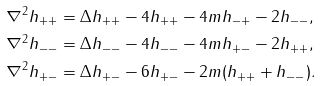<formula> <loc_0><loc_0><loc_500><loc_500>\nabla ^ { 2 } h _ { + + } & = \Delta h _ { + + } - 4 h _ { + + } - 4 m h _ { - + } - 2 h _ { - - } , \\ \nabla ^ { 2 } h _ { - - } & = \Delta h _ { - - } - 4 h _ { - - } - 4 m h _ { + - } - 2 h _ { + + } , \\ \nabla ^ { 2 } h _ { + - } & = \Delta h _ { + - } - 6 h _ { + - } - 2 m ( h _ { + + } + h _ { - - } ) .</formula> 